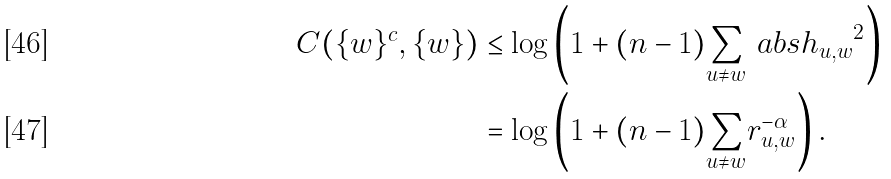<formula> <loc_0><loc_0><loc_500><loc_500>C ( \{ w \} ^ { c } , \{ w \} ) & \leq \log \left ( 1 + ( n - 1 ) { \sum _ { u \neq w } } \ a b s { h _ { u , w } } ^ { 2 } \right ) \\ & = \log \left ( 1 + ( n - 1 ) { \sum _ { u \neq w } } r _ { u , w } ^ { - \alpha } \right ) .</formula> 